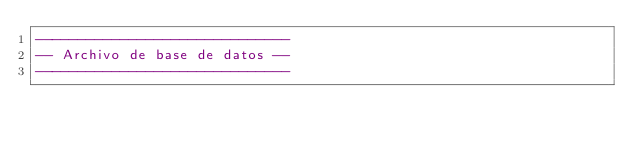Convert code to text. <code><loc_0><loc_0><loc_500><loc_500><_SQL_>------------------------------
-- Archivo de base de datos --
------------------------------

</code> 